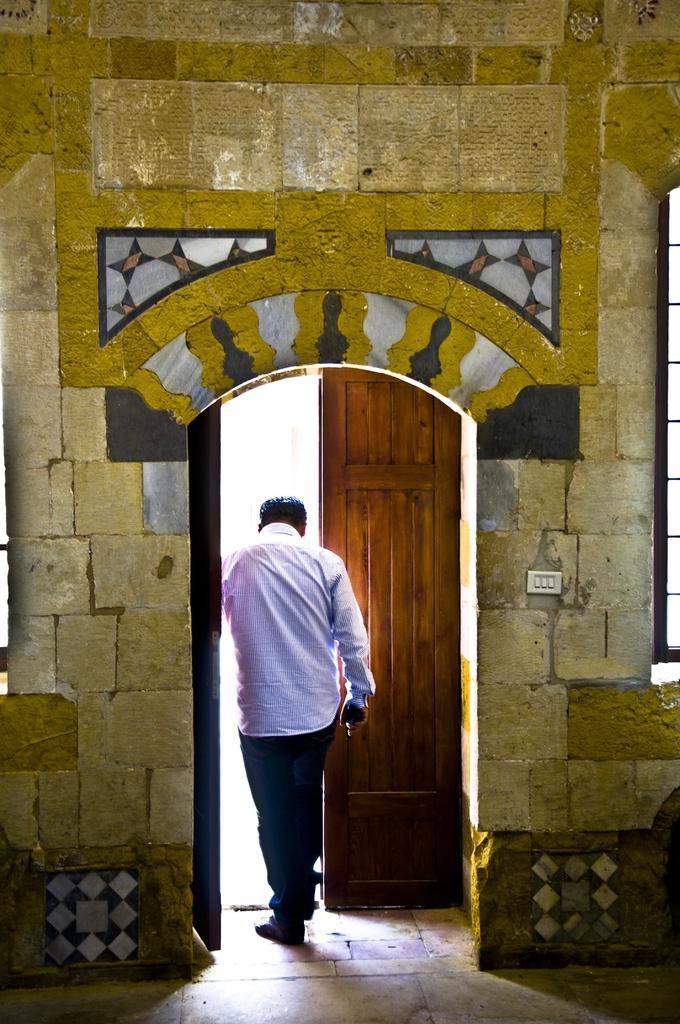Please provide a concise description of this image. In this image I can see a person walking. There is a door and a wall. There is a switchboard and a window on the right. 